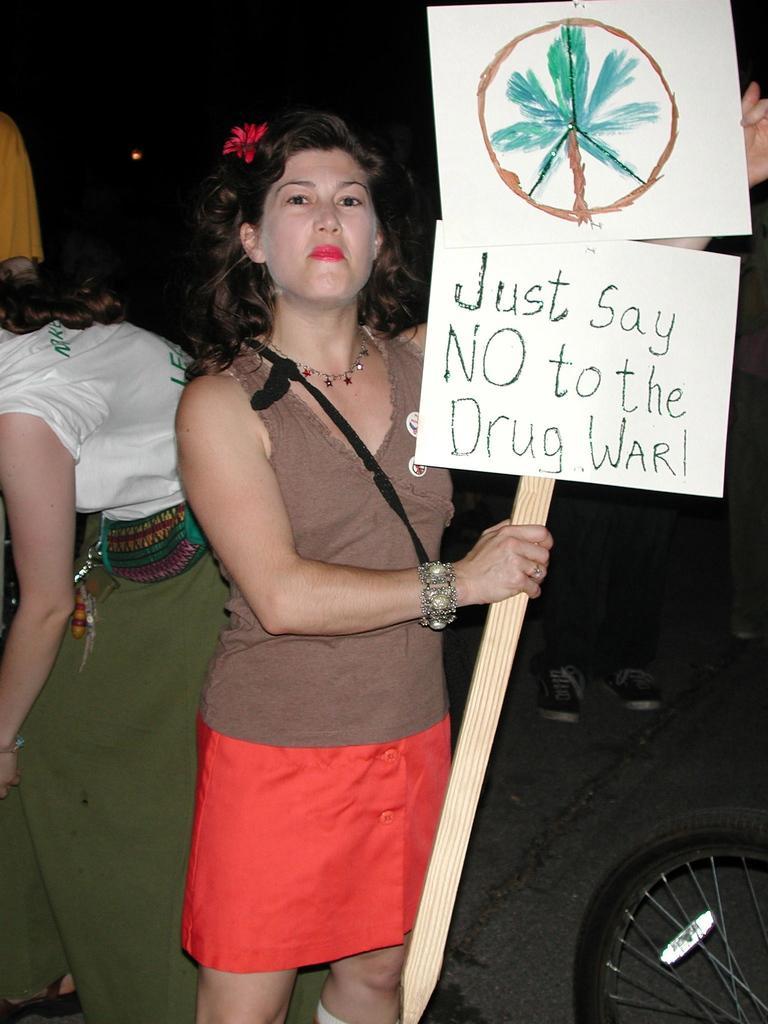Could you give a brief overview of what you see in this image? In this picture we can observe a woman wearing brown and red color dress, holding two white color boards fixed to cream color stick. In the left side there is another woman. We can observe a tire on the right side. In the background it is completely dark. 